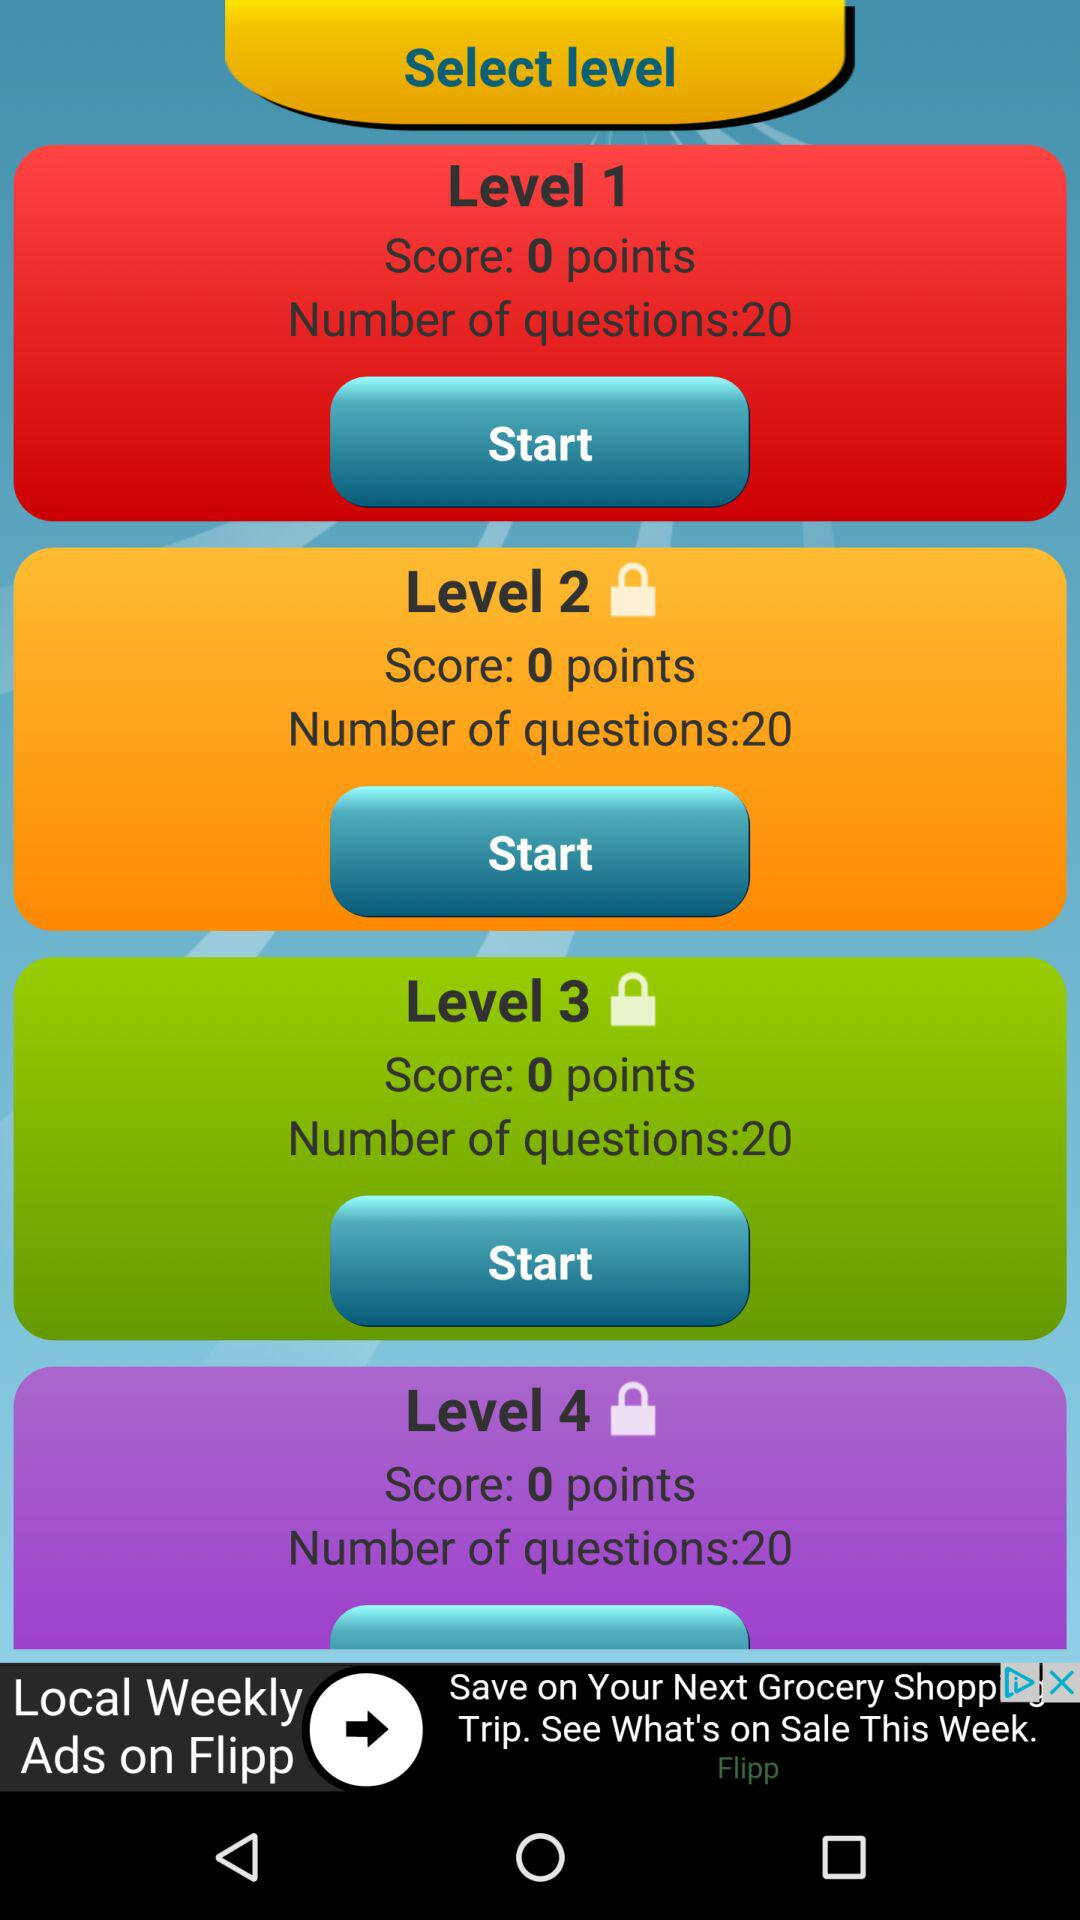How many levels are there?
Answer the question using a single word or phrase. 4 